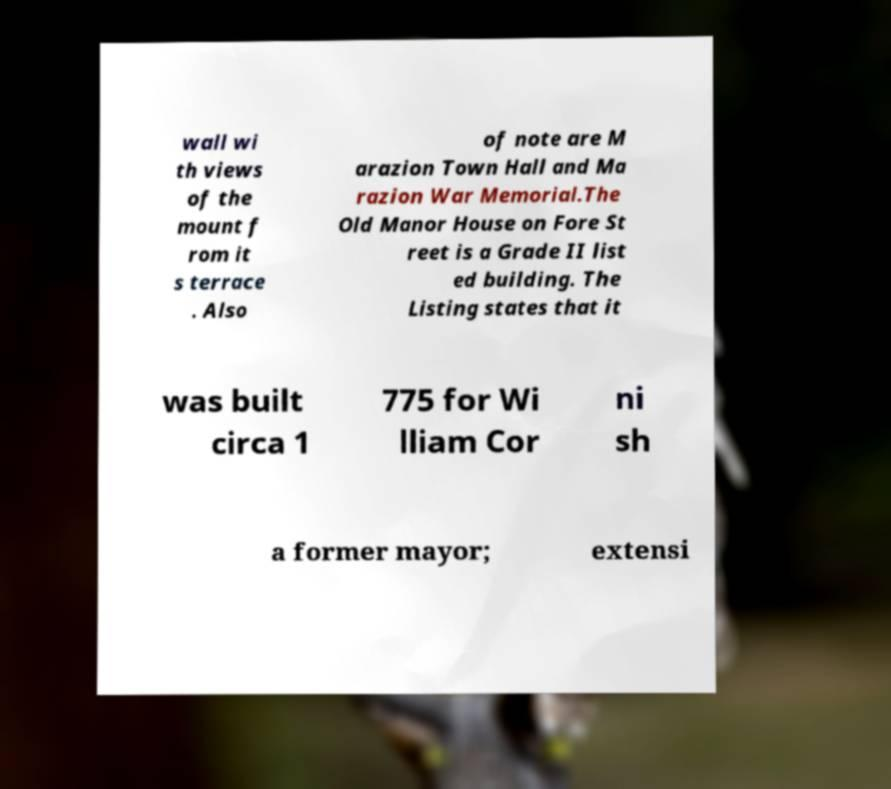For documentation purposes, I need the text within this image transcribed. Could you provide that? wall wi th views of the mount f rom it s terrace . Also of note are M arazion Town Hall and Ma razion War Memorial.The Old Manor House on Fore St reet is a Grade II list ed building. The Listing states that it was built circa 1 775 for Wi lliam Cor ni sh a former mayor; extensi 